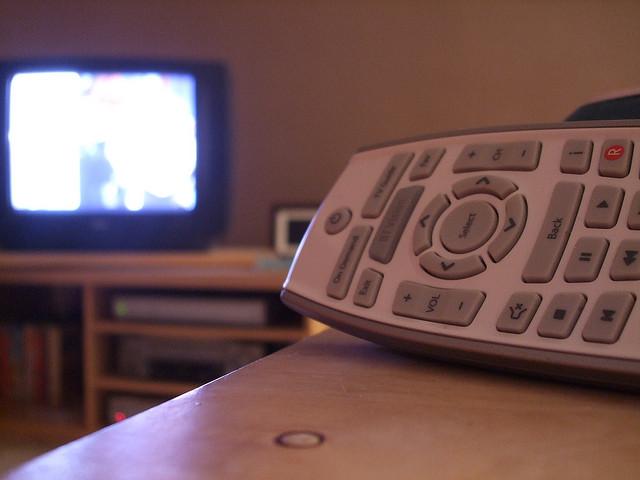What is black in this picture?
Keep it brief. Television. What character is on the TV?
Write a very short answer. Building. What does the remote control?
Concise answer only. Tv. What item is closest to the camera?
Short answer required. Remote. Is the 'record' button on the remote visible?
Write a very short answer. Yes. What shape is the remote?
Concise answer only. Rectangle. Is the TV new?
Answer briefly. No. Is the tv on?
Concise answer only. Yes. How many controls are in the picture?
Be succinct. 1. 